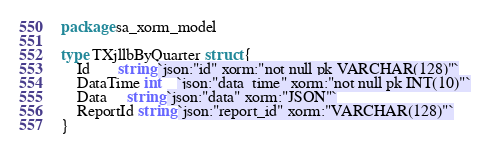<code> <loc_0><loc_0><loc_500><loc_500><_Go_>package sa_xorm_model

type TXjllbByQuarter struct {
	Id       string `json:"id" xorm:"not null pk VARCHAR(128)"`
	DataTime int    `json:"data_time" xorm:"not null pk INT(10)"`
	Data     string `json:"data" xorm:"JSON"`
	ReportId string `json:"report_id" xorm:"VARCHAR(128)"`
}
</code> 